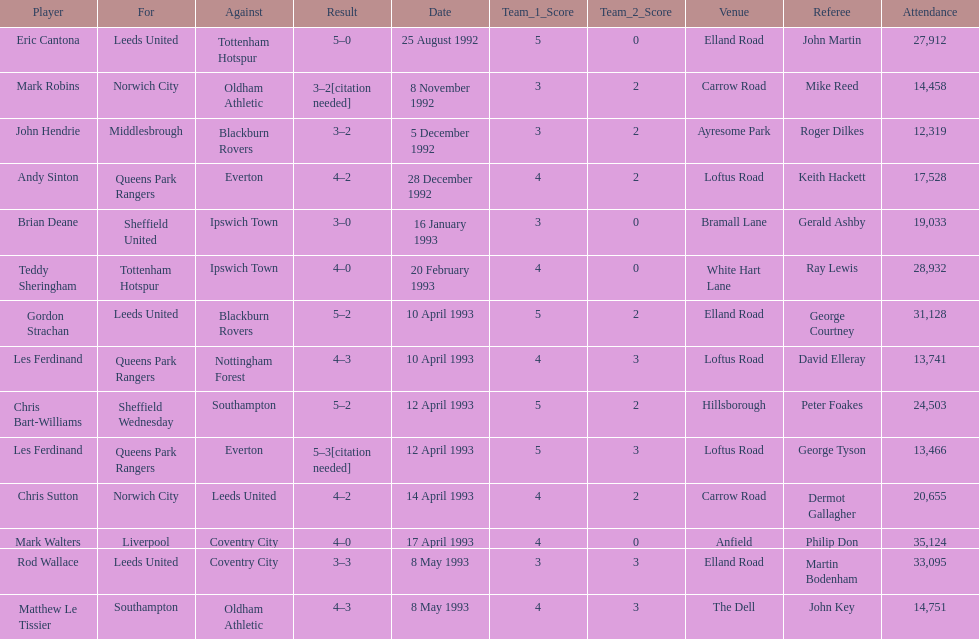Parse the full table. {'header': ['Player', 'For', 'Against', 'Result', 'Date', 'Team_1_Score', 'Team_2_Score', 'Venue', 'Referee', 'Attendance'], 'rows': [['Eric Cantona', 'Leeds United', 'Tottenham Hotspur', '5–0', '25 August 1992', '5', '0', 'Elland Road', 'John Martin', '27,912'], ['Mark Robins', 'Norwich City', 'Oldham Athletic', '3–2[citation needed]', '8 November 1992', '3', '2', 'Carrow Road', 'Mike Reed', '14,458'], ['John Hendrie', 'Middlesbrough', 'Blackburn Rovers', '3–2', '5 December 1992', '3', '2', 'Ayresome Park', 'Roger Dilkes', '12,319'], ['Andy Sinton', 'Queens Park Rangers', 'Everton', '4–2', '28 December 1992', '4', '2', 'Loftus Road', 'Keith Hackett', '17,528'], ['Brian Deane', 'Sheffield United', 'Ipswich Town', '3–0', '16 January 1993', '3', '0', 'Bramall Lane', 'Gerald Ashby', '19,033'], ['Teddy Sheringham', 'Tottenham Hotspur', 'Ipswich Town', '4–0', '20 February 1993', '4', '0', 'White Hart Lane', 'Ray Lewis', '28,932'], ['Gordon Strachan', 'Leeds United', 'Blackburn Rovers', '5–2', '10 April 1993', '5', '2', 'Elland Road', 'George Courtney', '31,128'], ['Les Ferdinand', 'Queens Park Rangers', 'Nottingham Forest', '4–3', '10 April 1993', '4', '3', 'Loftus Road', 'David Elleray', '13,741'], ['Chris Bart-Williams', 'Sheffield Wednesday', 'Southampton', '5–2', '12 April 1993', '5', '2', 'Hillsborough', 'Peter Foakes', '24,503'], ['Les Ferdinand', 'Queens Park Rangers', 'Everton', '5–3[citation needed]', '12 April 1993', '5', '3', 'Loftus Road', 'George Tyson', '13,466'], ['Chris Sutton', 'Norwich City', 'Leeds United', '4–2', '14 April 1993', '4', '2', 'Carrow Road', 'Dermot Gallagher', '20,655'], ['Mark Walters', 'Liverpool', 'Coventry City', '4–0', '17 April 1993', '4', '0', 'Anfield', 'Philip Don', '35,124'], ['Rod Wallace', 'Leeds United', 'Coventry City', '3–3', '8 May 1993', '3', '3', 'Elland Road', 'Martin Bodenham', '33,095'], ['Matthew Le Tissier', 'Southampton', 'Oldham Athletic', '4–3', '8 May 1993', '4', '3', 'The Dell', 'John Key', '14,751']]} What was the conclusion of the match between queens park rangers and everton? 4-2. 